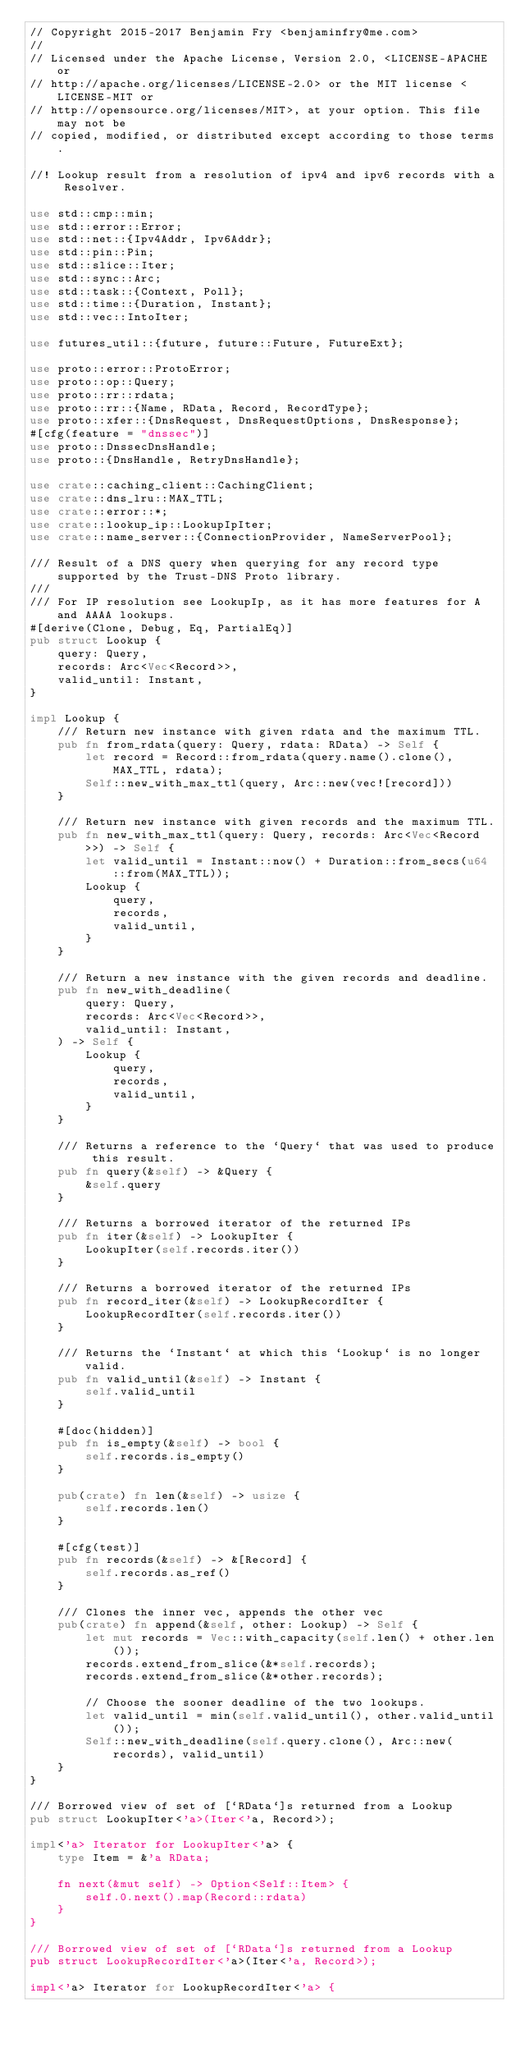Convert code to text. <code><loc_0><loc_0><loc_500><loc_500><_Rust_>// Copyright 2015-2017 Benjamin Fry <benjaminfry@me.com>
//
// Licensed under the Apache License, Version 2.0, <LICENSE-APACHE or
// http://apache.org/licenses/LICENSE-2.0> or the MIT license <LICENSE-MIT or
// http://opensource.org/licenses/MIT>, at your option. This file may not be
// copied, modified, or distributed except according to those terms.

//! Lookup result from a resolution of ipv4 and ipv6 records with a Resolver.

use std::cmp::min;
use std::error::Error;
use std::net::{Ipv4Addr, Ipv6Addr};
use std::pin::Pin;
use std::slice::Iter;
use std::sync::Arc;
use std::task::{Context, Poll};
use std::time::{Duration, Instant};
use std::vec::IntoIter;

use futures_util::{future, future::Future, FutureExt};

use proto::error::ProtoError;
use proto::op::Query;
use proto::rr::rdata;
use proto::rr::{Name, RData, Record, RecordType};
use proto::xfer::{DnsRequest, DnsRequestOptions, DnsResponse};
#[cfg(feature = "dnssec")]
use proto::DnssecDnsHandle;
use proto::{DnsHandle, RetryDnsHandle};

use crate::caching_client::CachingClient;
use crate::dns_lru::MAX_TTL;
use crate::error::*;
use crate::lookup_ip::LookupIpIter;
use crate::name_server::{ConnectionProvider, NameServerPool};

/// Result of a DNS query when querying for any record type supported by the Trust-DNS Proto library.
///
/// For IP resolution see LookupIp, as it has more features for A and AAAA lookups.
#[derive(Clone, Debug, Eq, PartialEq)]
pub struct Lookup {
    query: Query,
    records: Arc<Vec<Record>>,
    valid_until: Instant,
}

impl Lookup {
    /// Return new instance with given rdata and the maximum TTL.
    pub fn from_rdata(query: Query, rdata: RData) -> Self {
        let record = Record::from_rdata(query.name().clone(), MAX_TTL, rdata);
        Self::new_with_max_ttl(query, Arc::new(vec![record]))
    }

    /// Return new instance with given records and the maximum TTL.
    pub fn new_with_max_ttl(query: Query, records: Arc<Vec<Record>>) -> Self {
        let valid_until = Instant::now() + Duration::from_secs(u64::from(MAX_TTL));
        Lookup {
            query,
            records,
            valid_until,
        }
    }

    /// Return a new instance with the given records and deadline.
    pub fn new_with_deadline(
        query: Query,
        records: Arc<Vec<Record>>,
        valid_until: Instant,
    ) -> Self {
        Lookup {
            query,
            records,
            valid_until,
        }
    }

    /// Returns a reference to the `Query` that was used to produce this result.
    pub fn query(&self) -> &Query {
        &self.query
    }

    /// Returns a borrowed iterator of the returned IPs
    pub fn iter(&self) -> LookupIter {
        LookupIter(self.records.iter())
    }

    /// Returns a borrowed iterator of the returned IPs
    pub fn record_iter(&self) -> LookupRecordIter {
        LookupRecordIter(self.records.iter())
    }

    /// Returns the `Instant` at which this `Lookup` is no longer valid.
    pub fn valid_until(&self) -> Instant {
        self.valid_until
    }

    #[doc(hidden)]
    pub fn is_empty(&self) -> bool {
        self.records.is_empty()
    }

    pub(crate) fn len(&self) -> usize {
        self.records.len()
    }

    #[cfg(test)]
    pub fn records(&self) -> &[Record] {
        self.records.as_ref()
    }

    /// Clones the inner vec, appends the other vec
    pub(crate) fn append(&self, other: Lookup) -> Self {
        let mut records = Vec::with_capacity(self.len() + other.len());
        records.extend_from_slice(&*self.records);
        records.extend_from_slice(&*other.records);

        // Choose the sooner deadline of the two lookups.
        let valid_until = min(self.valid_until(), other.valid_until());
        Self::new_with_deadline(self.query.clone(), Arc::new(records), valid_until)
    }
}

/// Borrowed view of set of [`RData`]s returned from a Lookup
pub struct LookupIter<'a>(Iter<'a, Record>);

impl<'a> Iterator for LookupIter<'a> {
    type Item = &'a RData;

    fn next(&mut self) -> Option<Self::Item> {
        self.0.next().map(Record::rdata)
    }
}

/// Borrowed view of set of [`RData`]s returned from a Lookup
pub struct LookupRecordIter<'a>(Iter<'a, Record>);

impl<'a> Iterator for LookupRecordIter<'a> {</code> 